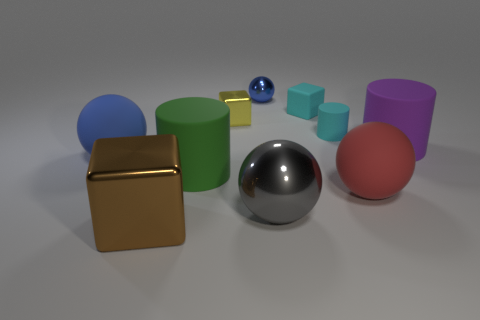Is the large red sphere made of the same material as the big green cylinder?
Give a very brief answer. Yes. What number of other shiny things are the same size as the gray object?
Your response must be concise. 1. Are there the same number of tiny blue shiny objects in front of the large green cylinder and cyan matte objects?
Offer a terse response. No. What number of big matte cylinders are both to the right of the red rubber object and on the left side of the red sphere?
Offer a very short reply. 0. There is a large shiny object to the left of the gray shiny sphere; does it have the same shape as the green thing?
Make the answer very short. No. There is a green thing that is the same size as the blue rubber thing; what is it made of?
Provide a succinct answer. Rubber. Are there an equal number of big brown cubes that are right of the gray sphere and large metal balls that are to the left of the blue metal thing?
Keep it short and to the point. Yes. There is a large matte cylinder in front of the large ball to the left of the blue shiny ball; what number of purple rubber cylinders are in front of it?
Offer a terse response. 0. There is a tiny metallic cube; is its color the same as the block right of the blue metal object?
Offer a terse response. No. What is the size of the red object that is made of the same material as the tiny cyan cylinder?
Ensure brevity in your answer.  Large. 